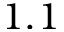Convert formula to latex. <formula><loc_0><loc_0><loc_500><loc_500>1 . 1</formula> 